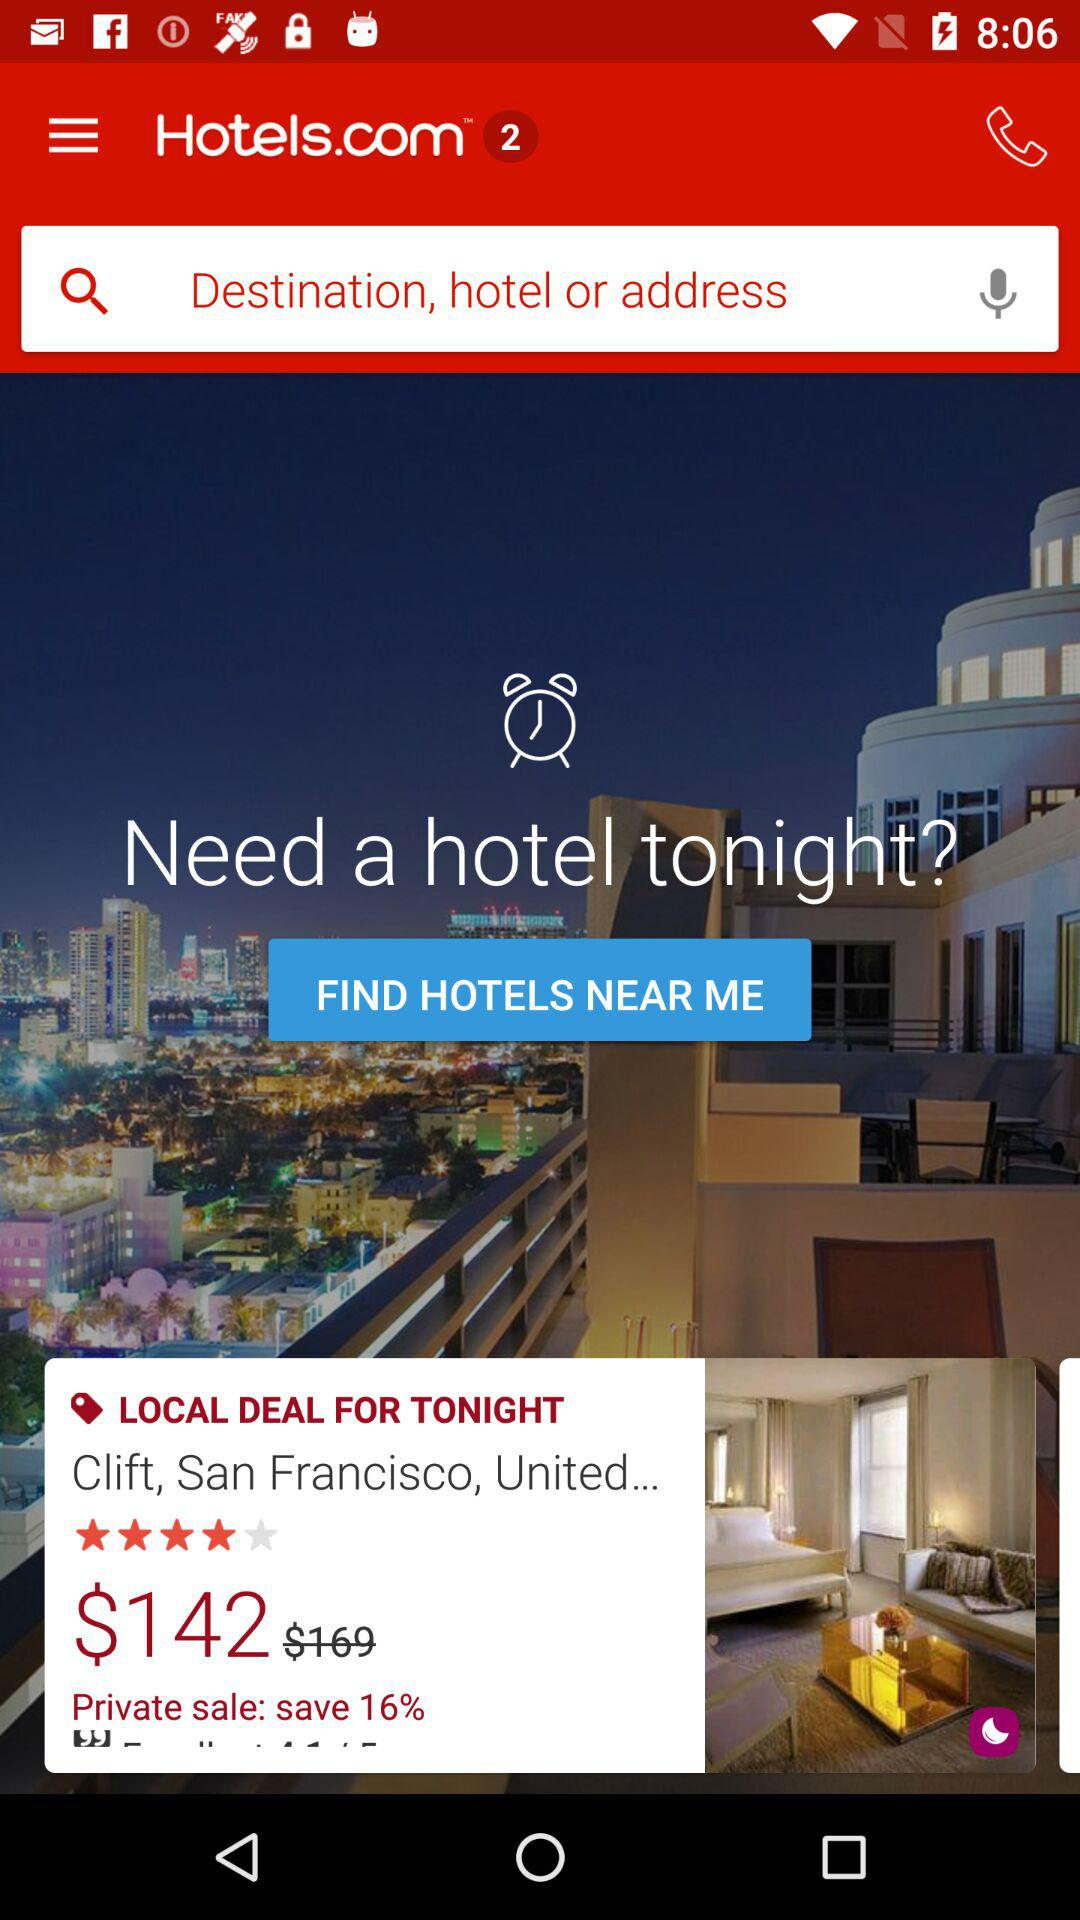What is the rating? The rating is 4 stars. 